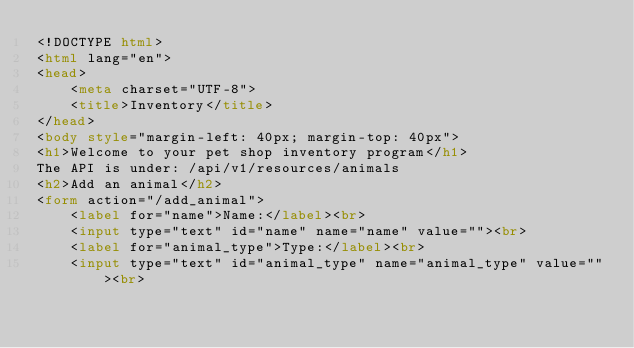Convert code to text. <code><loc_0><loc_0><loc_500><loc_500><_HTML_><!DOCTYPE html>
<html lang="en">
<head>
    <meta charset="UTF-8">
    <title>Inventory</title>
</head>
<body style="margin-left: 40px; margin-top: 40px">
<h1>Welcome to your pet shop inventory program</h1>
The API is under: /api/v1/resources/animals
<h2>Add an animal</h2>
<form action="/add_animal">
    <label for="name">Name:</label><br>
    <input type="text" id="name" name="name" value=""><br>
    <label for="animal_type">Type:</label><br>
    <input type="text" id="animal_type" name="animal_type" value=""><br></code> 